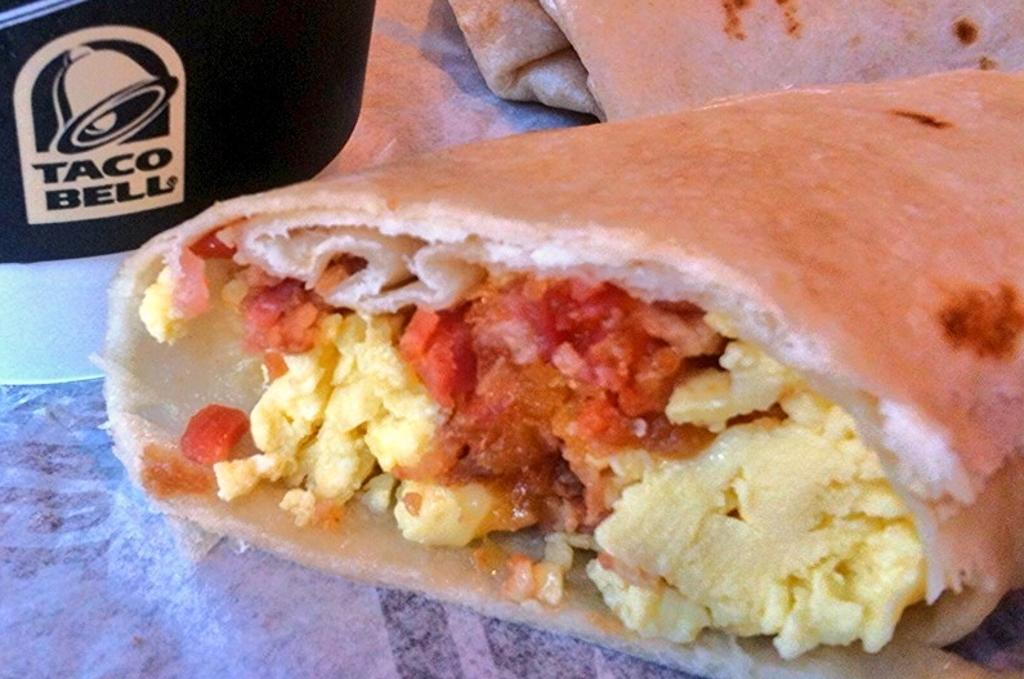What type of food is featured in the image? There is a taco bell tortilla in the image. What is inside the tortilla? The tortilla contains vegetables stuffing. What type of linen can be seen draped over the tortilla in the image? There is no linen present in the image; it features a taco bell tortilla with vegetables stuffing. How many boats are visible in the image? There are no boats present in the image. 